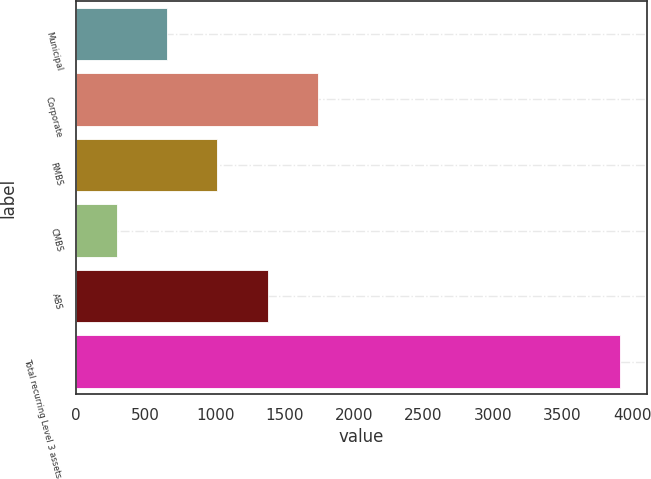Convert chart to OTSL. <chart><loc_0><loc_0><loc_500><loc_500><bar_chart><fcel>Municipal<fcel>Corporate<fcel>RMBS<fcel>CMBS<fcel>ABS<fcel>Total recurring Level 3 assets<nl><fcel>652.9<fcel>1738.6<fcel>1014.8<fcel>291<fcel>1376.7<fcel>3910<nl></chart> 